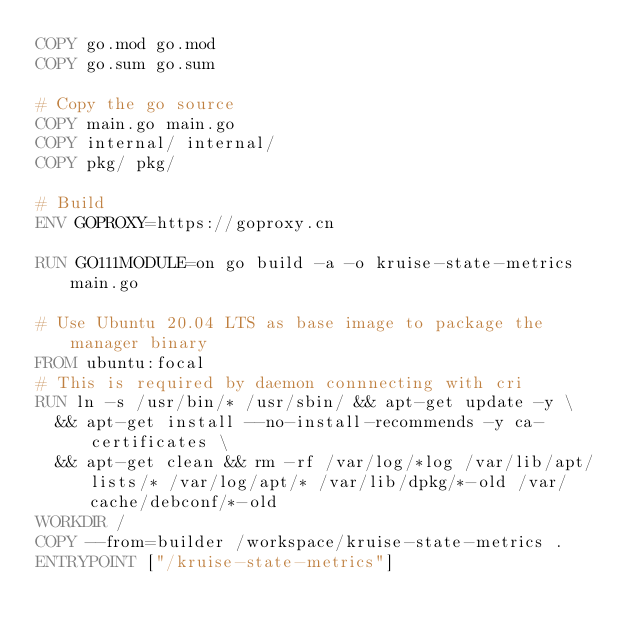<code> <loc_0><loc_0><loc_500><loc_500><_Dockerfile_>COPY go.mod go.mod
COPY go.sum go.sum

# Copy the go source
COPY main.go main.go
COPY internal/ internal/ 
COPY pkg/ pkg/

# Build
ENV GOPROXY=https://goproxy.cn

RUN GO111MODULE=on go build -a -o kruise-state-metrics main.go

# Use Ubuntu 20.04 LTS as base image to package the manager binary
FROM ubuntu:focal
# This is required by daemon connnecting with cri
RUN ln -s /usr/bin/* /usr/sbin/ && apt-get update -y \
  && apt-get install --no-install-recommends -y ca-certificates \
  && apt-get clean && rm -rf /var/log/*log /var/lib/apt/lists/* /var/log/apt/* /var/lib/dpkg/*-old /var/cache/debconf/*-old
WORKDIR /
COPY --from=builder /workspace/kruise-state-metrics .
ENTRYPOINT ["/kruise-state-metrics"]</code> 